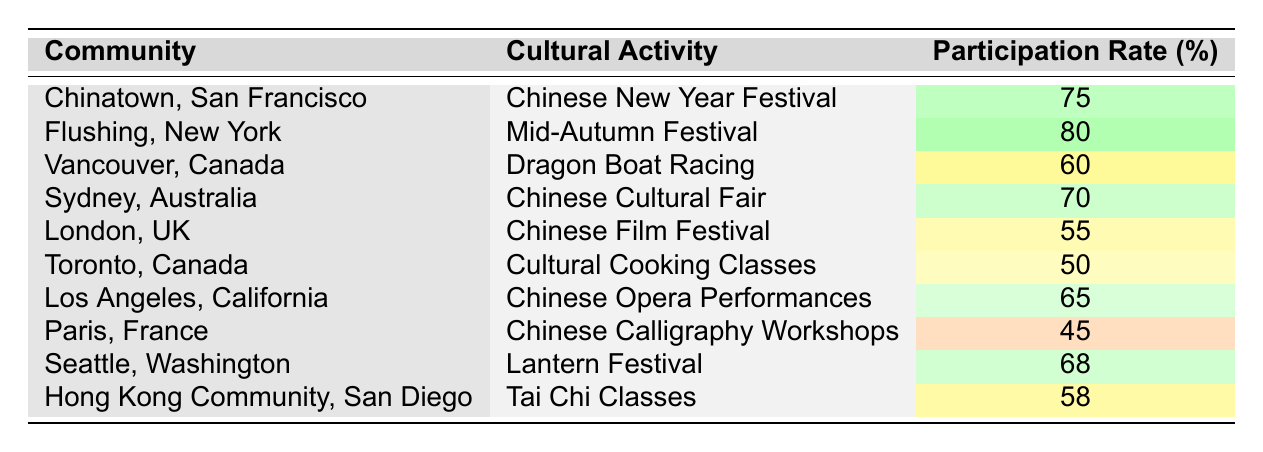What is the participation rate for the Chinese New Year Festival in Chinatown, San Francisco? The table indicates that the participation rate for the Chinese New Year Festival in Chinatown, San Francisco is listed directly under the respective columns. The corresponding value is 75%.
Answer: 75% Which cultural activity has the highest participation rate? By reviewing the participation rates listed in the table, Flushing, New York's Mid-Autumn Festival shows the highest rate at 80%.
Answer: 80% What is the average participation rate for the cultural activities listed in the table? To find the average, sum the participation rates: 75 + 80 + 60 + 70 + 55 + 50 + 65 + 45 + 68 + 58 =  676. Divide 676 by the number of events, which is 10, yielding an average participation rate of 67.6%.
Answer: 67.6% Is the participation rate for cultural cooking classes in Toronto higher than the participation rate for the Chinese film festival in London? The participation rate for cultural cooking classes in Toronto is 50%, while the Chinese film festival in London has a participation rate of 55%. Since 50% is not higher than 55%, the answer is no.
Answer: No How much higher is the participation rate for the Lantern Festival in Seattle compared to the participation rate for Chinese Calligraphy Workshops in Paris? The participation rate for the Lantern Festival in Seattle is 68%, and in Paris, it is 45%. The difference is calculated as 68% - 45% = 23%.
Answer: 23% 